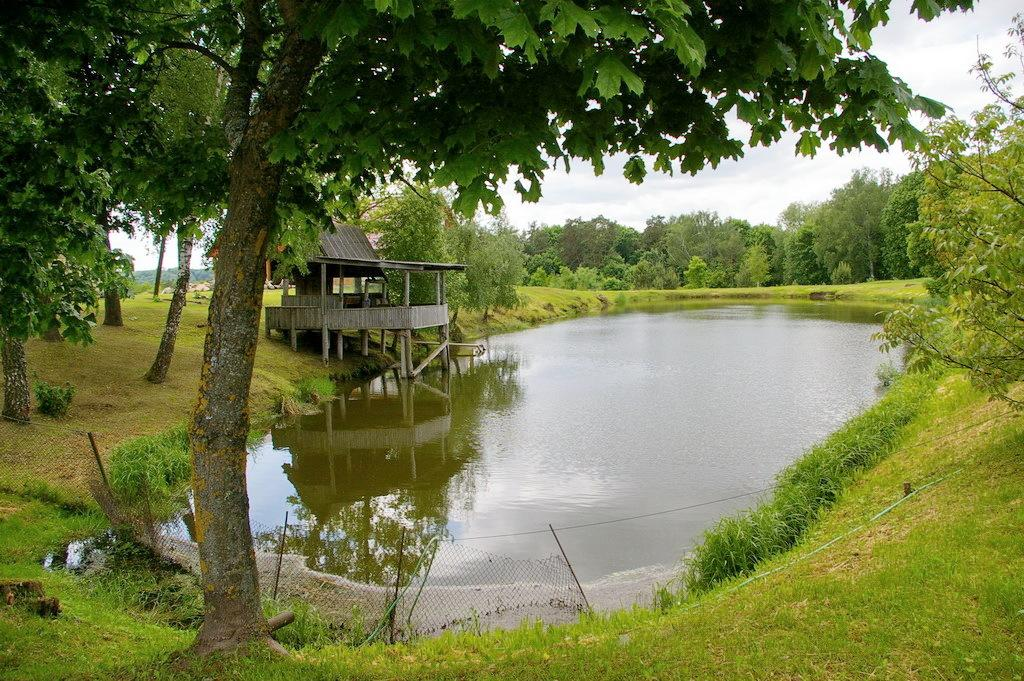What type of natural environment is depicted in the image? The image contains grass, water, and trees, which suggests a natural environment. What type of structure can be seen in the background of the image? There is a wooden house in the background of the image. What is the purpose of the fence in the image? The fence in the image may serve as a boundary or barrier. What is visible in the sky in the background of the image? The sky is visible in the background of the image. What type of club is being used to hit the kite in the image? There is no kite or club present in the image. 